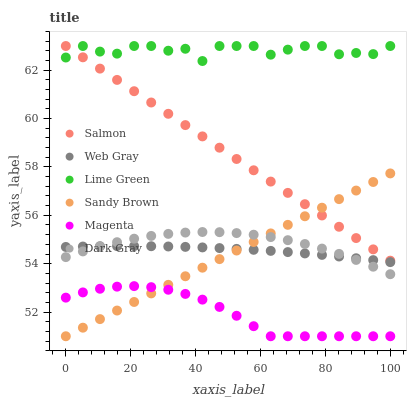Does Magenta have the minimum area under the curve?
Answer yes or no. Yes. Does Lime Green have the maximum area under the curve?
Answer yes or no. Yes. Does Sandy Brown have the minimum area under the curve?
Answer yes or no. No. Does Sandy Brown have the maximum area under the curve?
Answer yes or no. No. Is Salmon the smoothest?
Answer yes or no. Yes. Is Lime Green the roughest?
Answer yes or no. Yes. Is Sandy Brown the smoothest?
Answer yes or no. No. Is Sandy Brown the roughest?
Answer yes or no. No. Does Sandy Brown have the lowest value?
Answer yes or no. Yes. Does Salmon have the lowest value?
Answer yes or no. No. Does Lime Green have the highest value?
Answer yes or no. Yes. Does Sandy Brown have the highest value?
Answer yes or no. No. Is Magenta less than Dark Gray?
Answer yes or no. Yes. Is Salmon greater than Magenta?
Answer yes or no. Yes. Does Sandy Brown intersect Magenta?
Answer yes or no. Yes. Is Sandy Brown less than Magenta?
Answer yes or no. No. Is Sandy Brown greater than Magenta?
Answer yes or no. No. Does Magenta intersect Dark Gray?
Answer yes or no. No. 